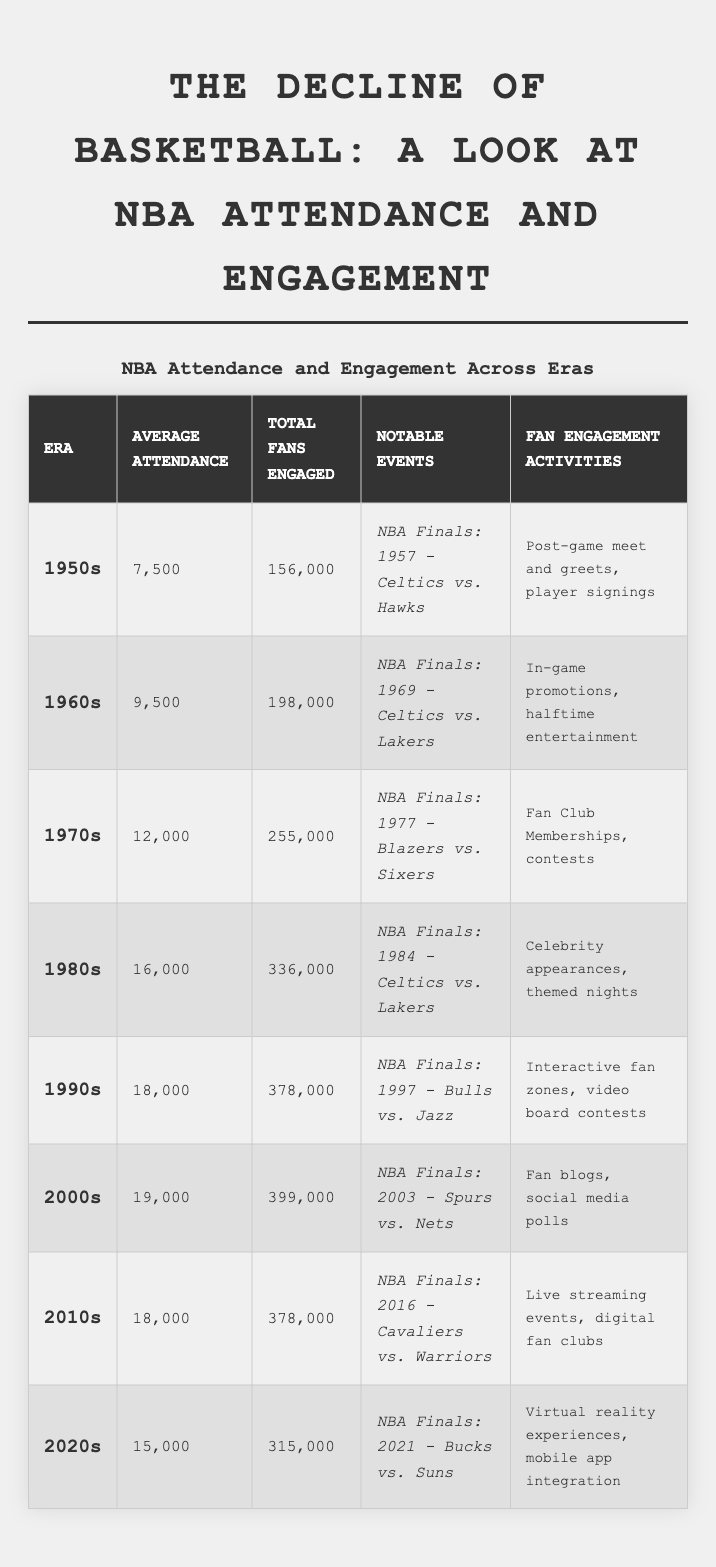What era had the highest average attendance? By reviewing the average attendance column, the 2000s had the highest value of 19,000.
Answer: 2000s What was the total number of fans engaged in the 1980s? According to the total fans engaged column, the 1980s had 336,000 fans engaged.
Answer: 336,000 Did the average attendance in the 1950s exceed 8,000? The table shows that the average attendance in the 1950s was 7,500, which is less than 8,000.
Answer: No What was the difference in total fans engaged between the 1990s and the 2000s? Total fans engaged in 1990s: 378,000; in 2000s: 399,000. The difference is 399,000 - 378,000 = 21,000.
Answer: 21,000 What era saw a decrease in average attendance compared to the previous decade? By comparing the average attendances: 2000s (19,000) to 2010s (18,000) shows a drop of 1,000.
Answer: 2010s Which era had notable events featuring the Lakers? The table lists notable events for the 1960s and 1980s as both featuring the Lakers in the finals.
Answer: 1960s, 1980s What was the average attendance of the 1970s compared to the 2020s? Average attendance for 1970s was 12,000 and for 2020s was 15,000. The 2020s had 3,000 more than the 1970s.
Answer: 15,000 compared to 12,000 Was there an increase in total fans engaged from the 1960s to the 1970s? The total fans engaged increased from 198,000 in the 1960s to 255,000 in the 1970s, indicating an increase.
Answer: Yes What were the fan engagement activities in the 1990s? The table specifies that the fan engagement activities in the 1990s included interactive fan zones and video board contests.
Answer: Interactive fan zones, video board contests How many total fans were engaged in the 1950s compared to the 2020s? Total fans engaged in the 1950s: 156,000; in the 2020s: 315,000. The 2020s engaged 159,000 more fans.
Answer: 156,000 compared to 315,000 What pattern can be observed in average attendance from the 1950s to the 2010s? The average attendance generally increased from the 1950s to the 1990s, peaked in the 2000s, and then decreased in the 2010s.
Answer: Increased then decreased 